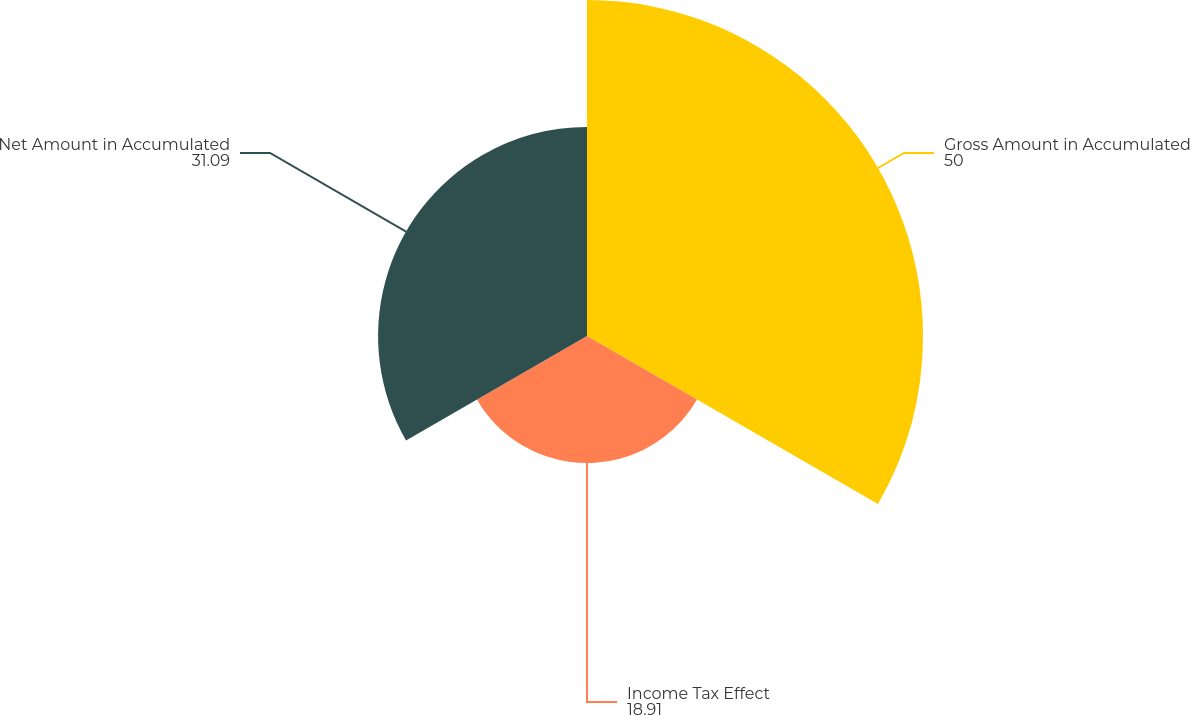Convert chart to OTSL. <chart><loc_0><loc_0><loc_500><loc_500><pie_chart><fcel>Gross Amount in Accumulated<fcel>Income Tax Effect<fcel>Net Amount in Accumulated<nl><fcel>50.0%<fcel>18.91%<fcel>31.09%<nl></chart> 